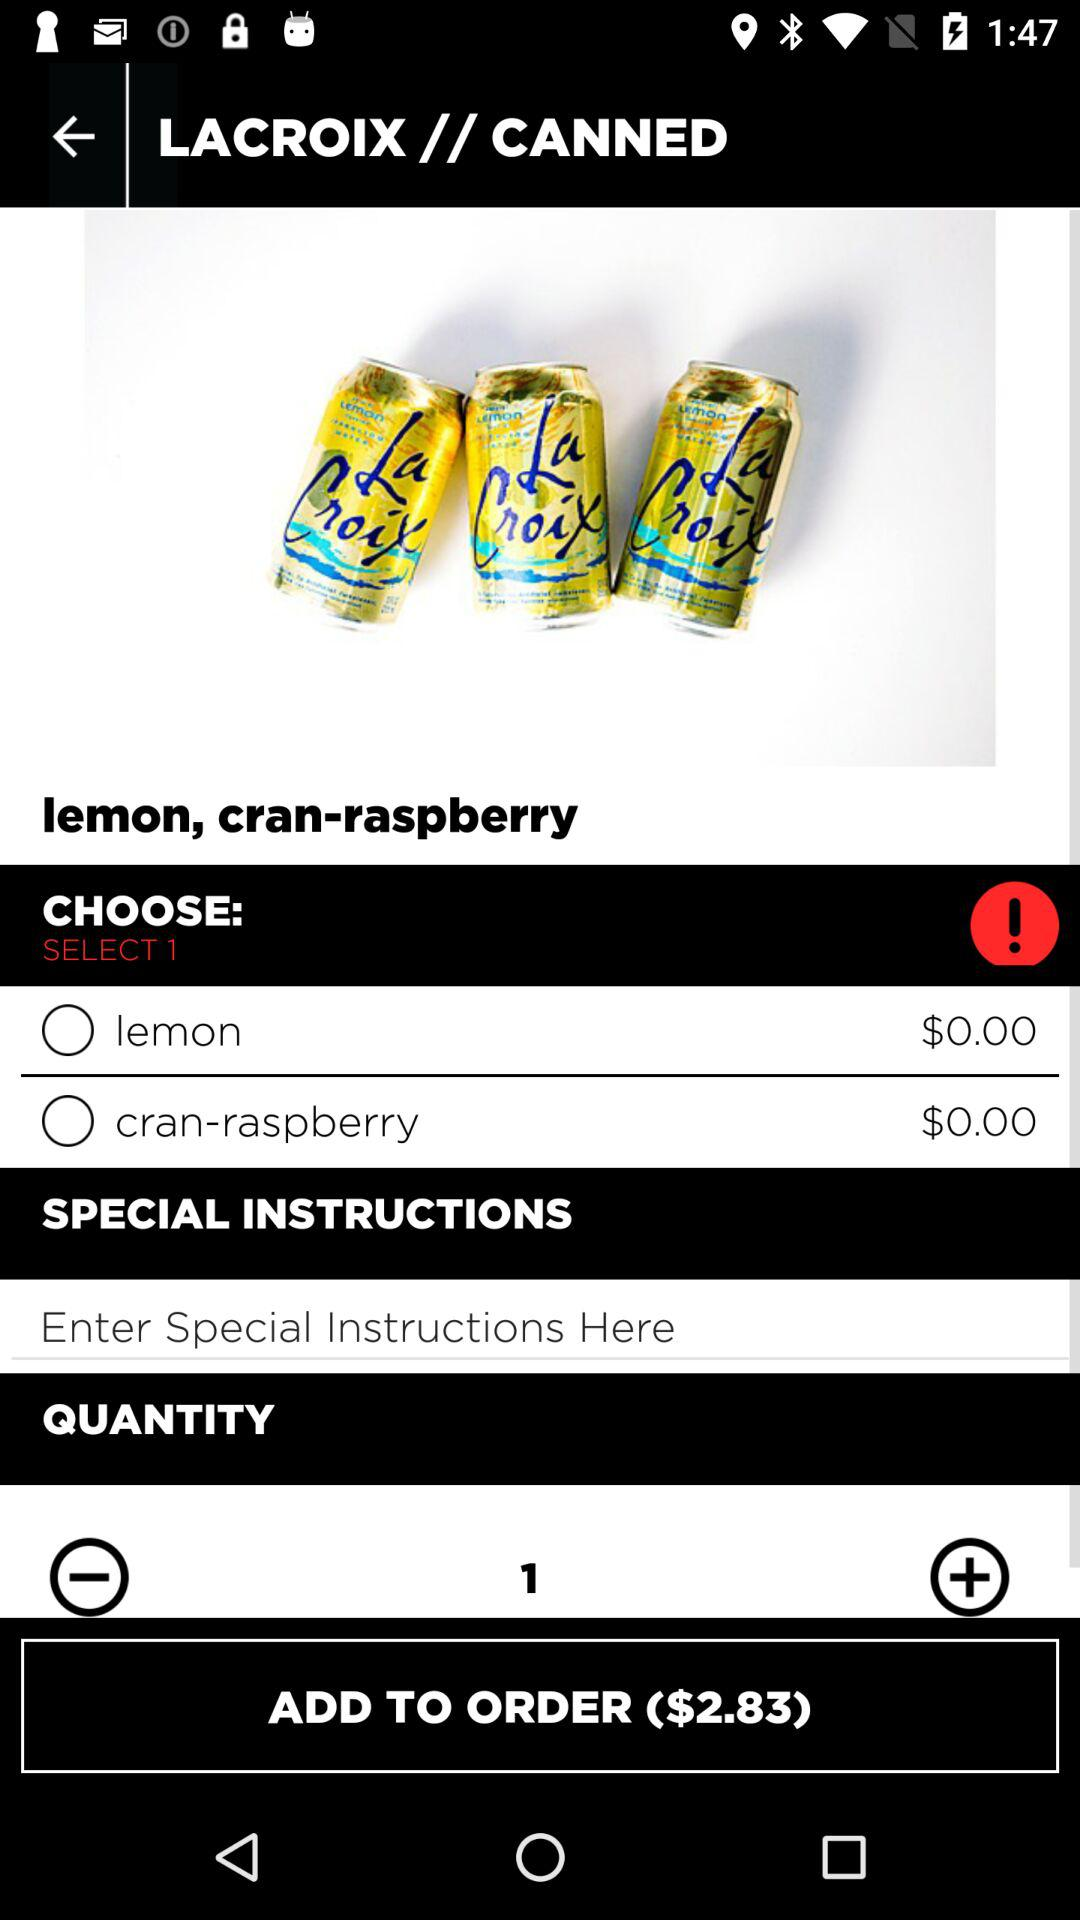How much money do I need to pay to order "LACROIX // CANNED"? You need to pay $2.83 to order "LACROIX // CANNED". 